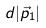Convert formula to latex. <formula><loc_0><loc_0><loc_500><loc_500>d | \vec { p } _ { 1 } |</formula> 